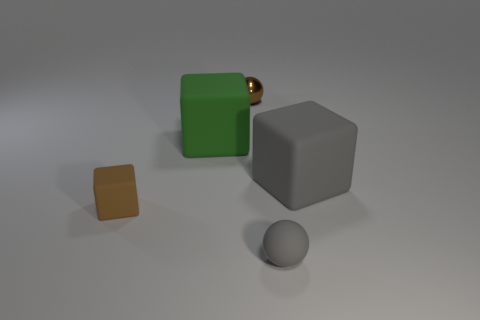There is a rubber block behind the large gray rubber object; is its size the same as the gray rubber object behind the brown cube?
Make the answer very short. Yes. Are there any other big things made of the same material as the big green object?
Offer a terse response. Yes. There is a cube that is the same color as the small matte sphere; what size is it?
Give a very brief answer. Large. Is there a large gray thing left of the small ball in front of the small matte block in front of the small brown metallic object?
Provide a short and direct response. No. Are there any small objects to the right of the tiny brown sphere?
Your response must be concise. Yes. There is a large matte thing on the left side of the large gray rubber object; what number of rubber cubes are in front of it?
Provide a short and direct response. 2. There is a green rubber object; does it have the same size as the cube on the right side of the small brown shiny object?
Your answer should be compact. Yes. Is there another tiny matte ball that has the same color as the tiny rubber sphere?
Your response must be concise. No. There is a gray block that is the same material as the tiny brown cube; what is its size?
Your response must be concise. Large. Is the green block made of the same material as the gray sphere?
Provide a succinct answer. Yes. 